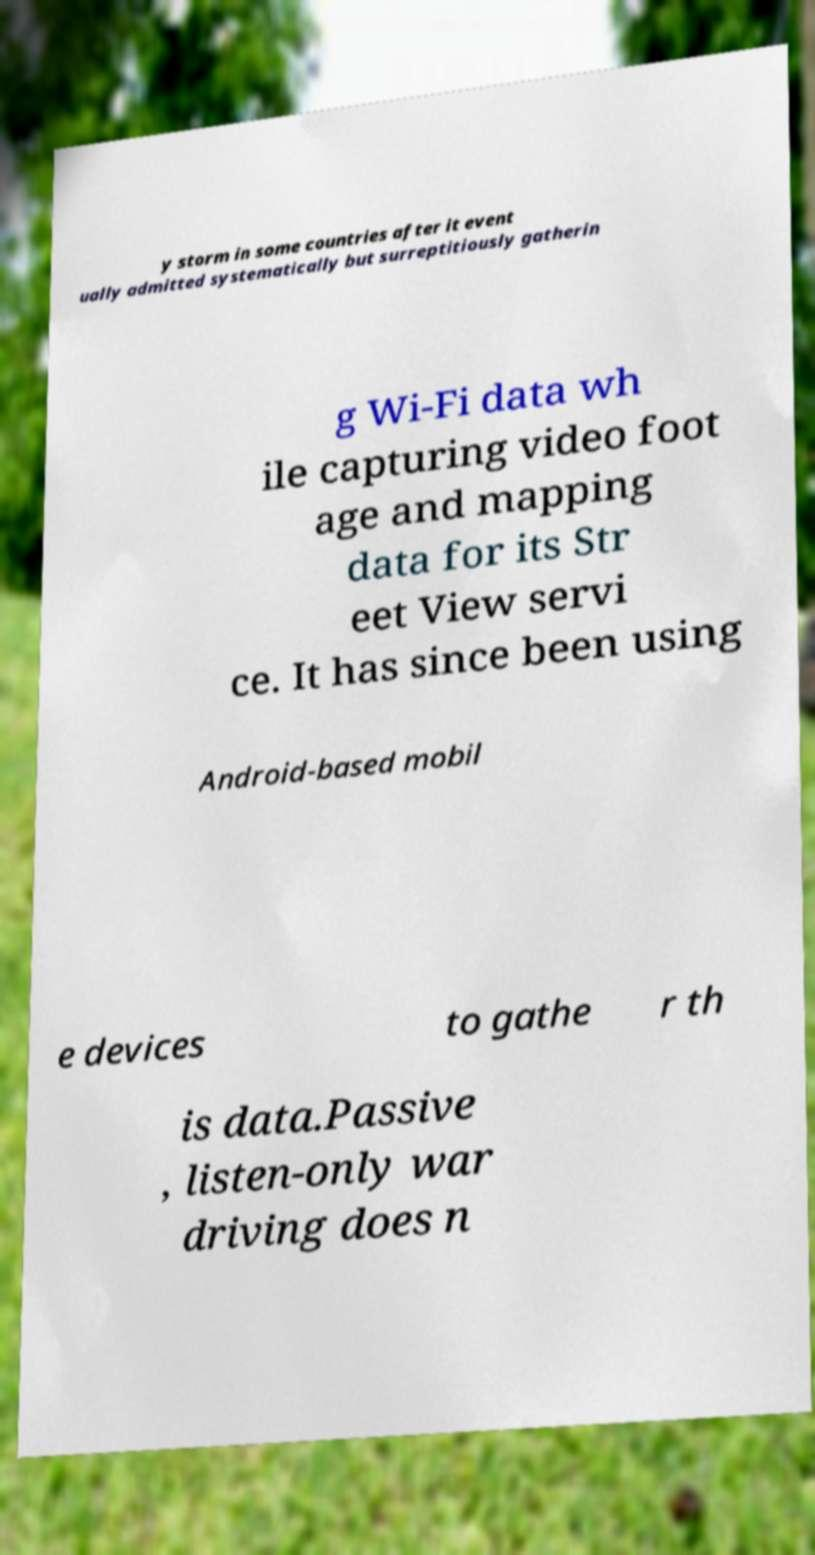For documentation purposes, I need the text within this image transcribed. Could you provide that? y storm in some countries after it event ually admitted systematically but surreptitiously gatherin g Wi-Fi data wh ile capturing video foot age and mapping data for its Str eet View servi ce. It has since been using Android-based mobil e devices to gathe r th is data.Passive , listen-only war driving does n 